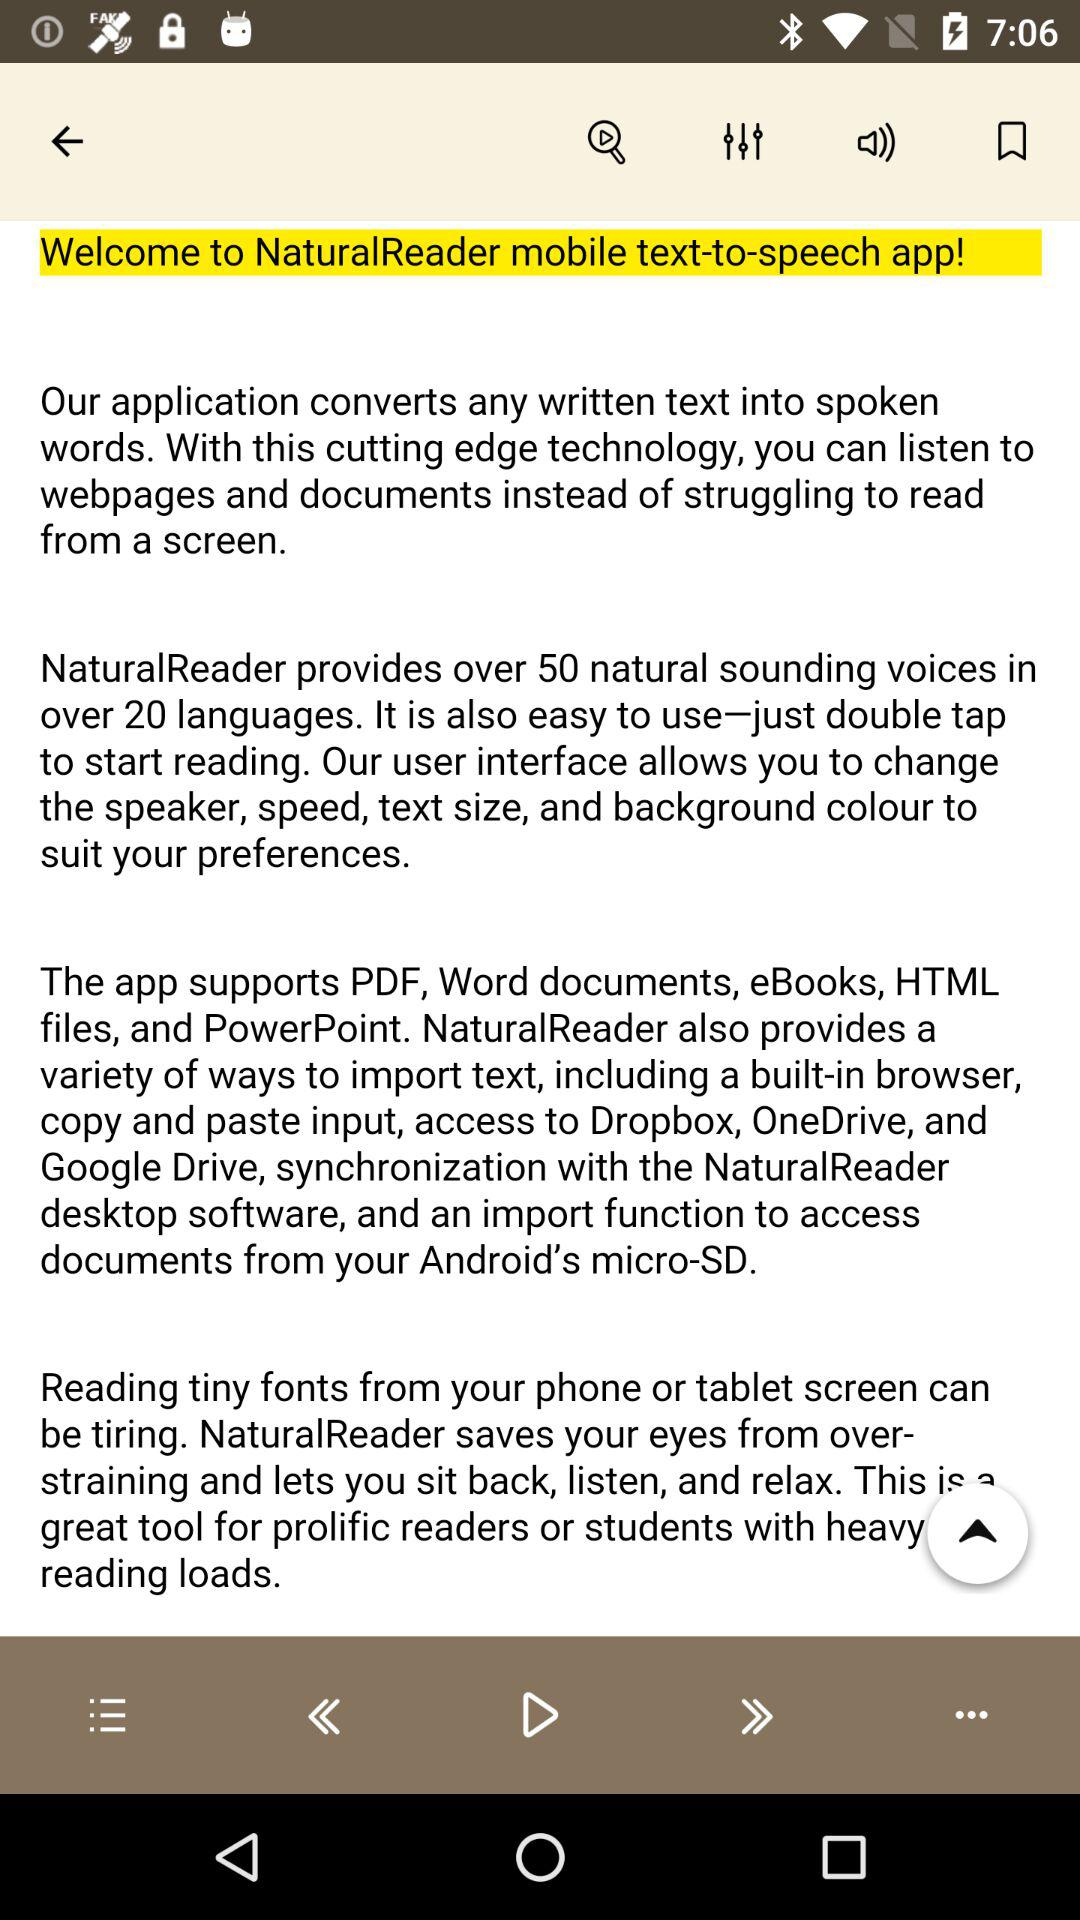What is the application name? The application name is "NaturalReader mobile text-to-speech". 